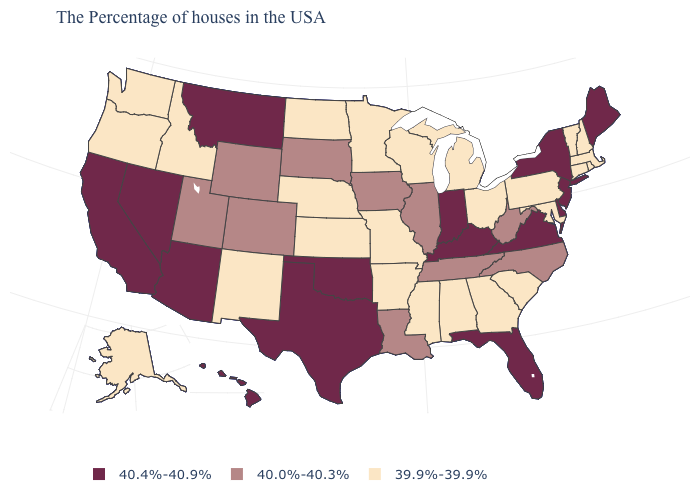Which states have the highest value in the USA?
Short answer required. Maine, New York, New Jersey, Delaware, Virginia, Florida, Kentucky, Indiana, Oklahoma, Texas, Montana, Arizona, Nevada, California, Hawaii. Which states have the highest value in the USA?
Short answer required. Maine, New York, New Jersey, Delaware, Virginia, Florida, Kentucky, Indiana, Oklahoma, Texas, Montana, Arizona, Nevada, California, Hawaii. Among the states that border Connecticut , does Rhode Island have the lowest value?
Quick response, please. Yes. Name the states that have a value in the range 40.0%-40.3%?
Be succinct. North Carolina, West Virginia, Tennessee, Illinois, Louisiana, Iowa, South Dakota, Wyoming, Colorado, Utah. Does Maine have the same value as Delaware?
Give a very brief answer. Yes. Name the states that have a value in the range 40.0%-40.3%?
Short answer required. North Carolina, West Virginia, Tennessee, Illinois, Louisiana, Iowa, South Dakota, Wyoming, Colorado, Utah. Does Missouri have the same value as Alaska?
Answer briefly. Yes. Does California have the highest value in the USA?
Concise answer only. Yes. Does Florida have the highest value in the USA?
Short answer required. Yes. Which states hav the highest value in the South?
Give a very brief answer. Delaware, Virginia, Florida, Kentucky, Oklahoma, Texas. Does the map have missing data?
Short answer required. No. What is the highest value in states that border Alabama?
Be succinct. 40.4%-40.9%. What is the value of Florida?
Short answer required. 40.4%-40.9%. Is the legend a continuous bar?
Quick response, please. No. 